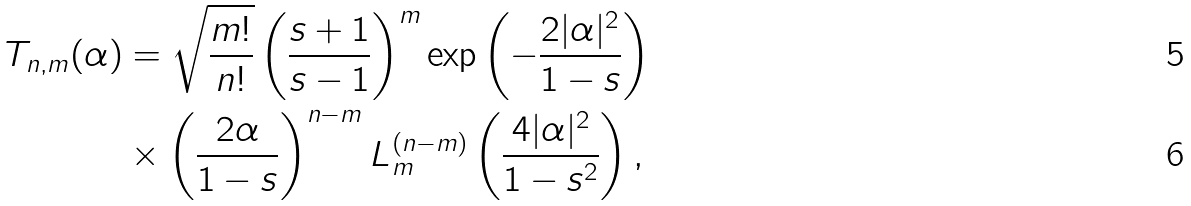<formula> <loc_0><loc_0><loc_500><loc_500>T _ { n , m } ( \alpha ) & = \sqrt { \frac { m ! } { n ! } } \left ( \frac { s + 1 } { s - 1 } \right ) ^ { m } \exp \left ( - \frac { 2 | \alpha | ^ { 2 } } { 1 - s } \right ) \\ & \times \left ( \frac { 2 \alpha } { 1 - s } \right ) ^ { n - m } L _ { m } ^ { ( n - m ) } \left ( \frac { 4 | \alpha | ^ { 2 } } { 1 - s ^ { 2 } } \right ) ,</formula> 